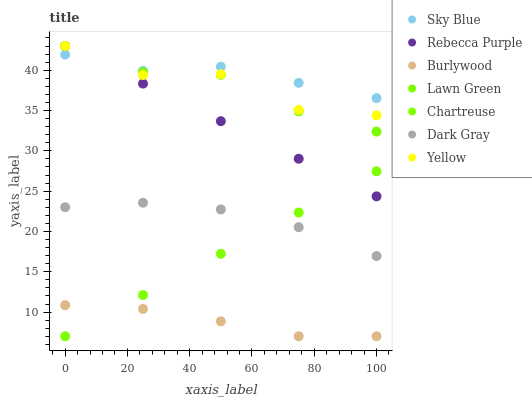Does Burlywood have the minimum area under the curve?
Answer yes or no. Yes. Does Sky Blue have the maximum area under the curve?
Answer yes or no. Yes. Does Yellow have the minimum area under the curve?
Answer yes or no. No. Does Yellow have the maximum area under the curve?
Answer yes or no. No. Is Chartreuse the smoothest?
Answer yes or no. Yes. Is Yellow the roughest?
Answer yes or no. Yes. Is Burlywood the smoothest?
Answer yes or no. No. Is Burlywood the roughest?
Answer yes or no. No. Does Burlywood have the lowest value?
Answer yes or no. Yes. Does Yellow have the lowest value?
Answer yes or no. No. Does Rebecca Purple have the highest value?
Answer yes or no. Yes. Does Burlywood have the highest value?
Answer yes or no. No. Is Burlywood less than Rebecca Purple?
Answer yes or no. Yes. Is Sky Blue greater than Dark Gray?
Answer yes or no. Yes. Does Sky Blue intersect Lawn Green?
Answer yes or no. Yes. Is Sky Blue less than Lawn Green?
Answer yes or no. No. Is Sky Blue greater than Lawn Green?
Answer yes or no. No. Does Burlywood intersect Rebecca Purple?
Answer yes or no. No. 